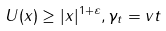Convert formula to latex. <formula><loc_0><loc_0><loc_500><loc_500>U ( x ) \geq | x | ^ { 1 + \varepsilon } , \gamma _ { t } = v t</formula> 